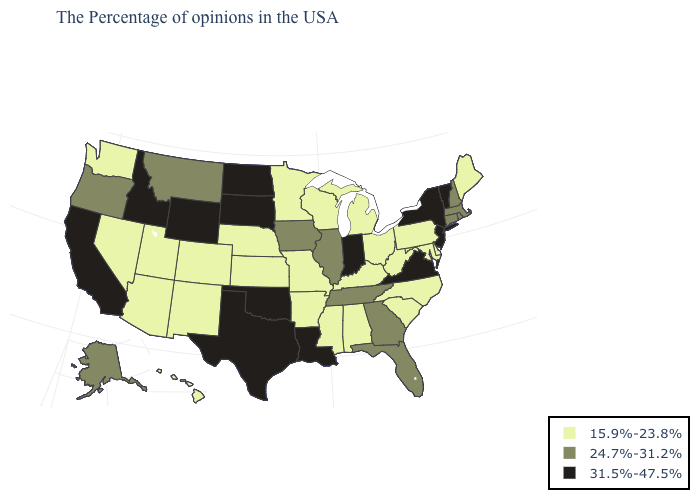Does Pennsylvania have a higher value than New York?
Give a very brief answer. No. What is the value of Colorado?
Short answer required. 15.9%-23.8%. Name the states that have a value in the range 24.7%-31.2%?
Concise answer only. Massachusetts, Rhode Island, New Hampshire, Connecticut, Florida, Georgia, Tennessee, Illinois, Iowa, Montana, Oregon, Alaska. What is the value of Missouri?
Answer briefly. 15.9%-23.8%. Which states have the lowest value in the Northeast?
Answer briefly. Maine, Pennsylvania. Does New York have a lower value than Michigan?
Answer briefly. No. Does Ohio have the same value as New Hampshire?
Be succinct. No. Among the states that border Minnesota , does Iowa have the highest value?
Short answer required. No. Which states have the lowest value in the MidWest?
Keep it brief. Ohio, Michigan, Wisconsin, Missouri, Minnesota, Kansas, Nebraska. What is the lowest value in the West?
Keep it brief. 15.9%-23.8%. Name the states that have a value in the range 31.5%-47.5%?
Quick response, please. Vermont, New York, New Jersey, Virginia, Indiana, Louisiana, Oklahoma, Texas, South Dakota, North Dakota, Wyoming, Idaho, California. Name the states that have a value in the range 24.7%-31.2%?
Concise answer only. Massachusetts, Rhode Island, New Hampshire, Connecticut, Florida, Georgia, Tennessee, Illinois, Iowa, Montana, Oregon, Alaska. Name the states that have a value in the range 15.9%-23.8%?
Keep it brief. Maine, Delaware, Maryland, Pennsylvania, North Carolina, South Carolina, West Virginia, Ohio, Michigan, Kentucky, Alabama, Wisconsin, Mississippi, Missouri, Arkansas, Minnesota, Kansas, Nebraska, Colorado, New Mexico, Utah, Arizona, Nevada, Washington, Hawaii. What is the lowest value in the USA?
Quick response, please. 15.9%-23.8%. Name the states that have a value in the range 24.7%-31.2%?
Give a very brief answer. Massachusetts, Rhode Island, New Hampshire, Connecticut, Florida, Georgia, Tennessee, Illinois, Iowa, Montana, Oregon, Alaska. 